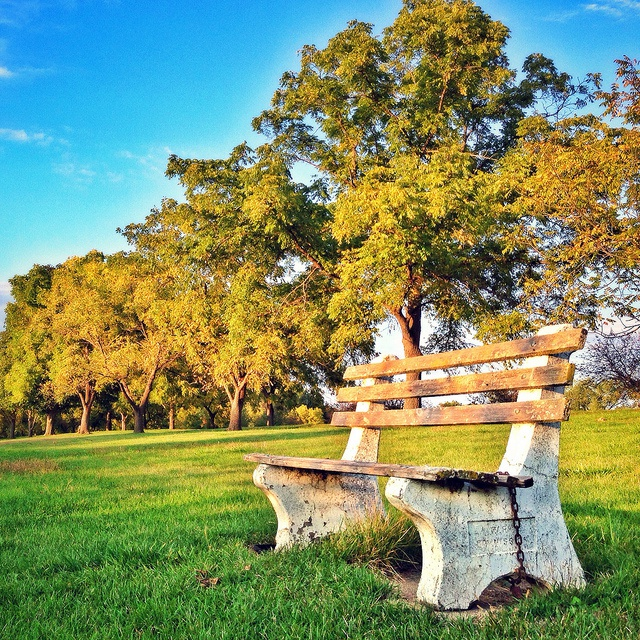Describe the objects in this image and their specific colors. I can see a bench in lightblue, ivory, orange, darkgray, and tan tones in this image. 